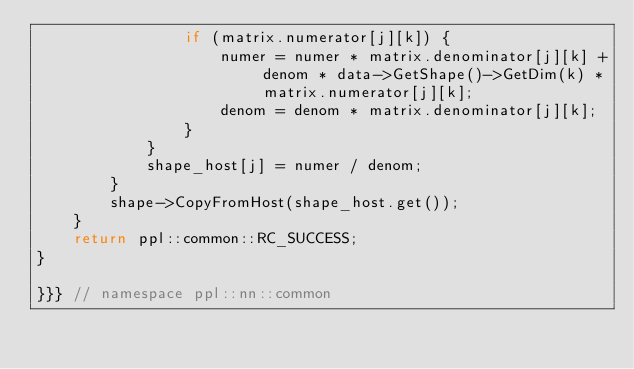<code> <loc_0><loc_0><loc_500><loc_500><_C++_>                if (matrix.numerator[j][k]) {
                    numer = numer * matrix.denominator[j][k] + denom * data->GetShape()->GetDim(k) * matrix.numerator[j][k];
                    denom = denom * matrix.denominator[j][k];
                }
            }
            shape_host[j] = numer / denom;
        }
        shape->CopyFromHost(shape_host.get());
    }
    return ppl::common::RC_SUCCESS;
}

}}} // namespace ppl::nn::common
</code> 